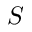Convert formula to latex. <formula><loc_0><loc_0><loc_500><loc_500>S</formula> 